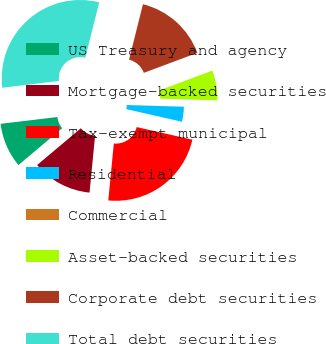Convert chart. <chart><loc_0><loc_0><loc_500><loc_500><pie_chart><fcel>US Treasury and agency<fcel>Mortgage-backed securities<fcel>Tax-exempt municipal<fcel>Residential<fcel>Commercial<fcel>Asset-backed securities<fcel>Corporate debt securities<fcel>Total debt securities<nl><fcel>9.24%<fcel>12.32%<fcel>22.99%<fcel>3.08%<fcel>0.0%<fcel>6.16%<fcel>15.4%<fcel>30.8%<nl></chart> 